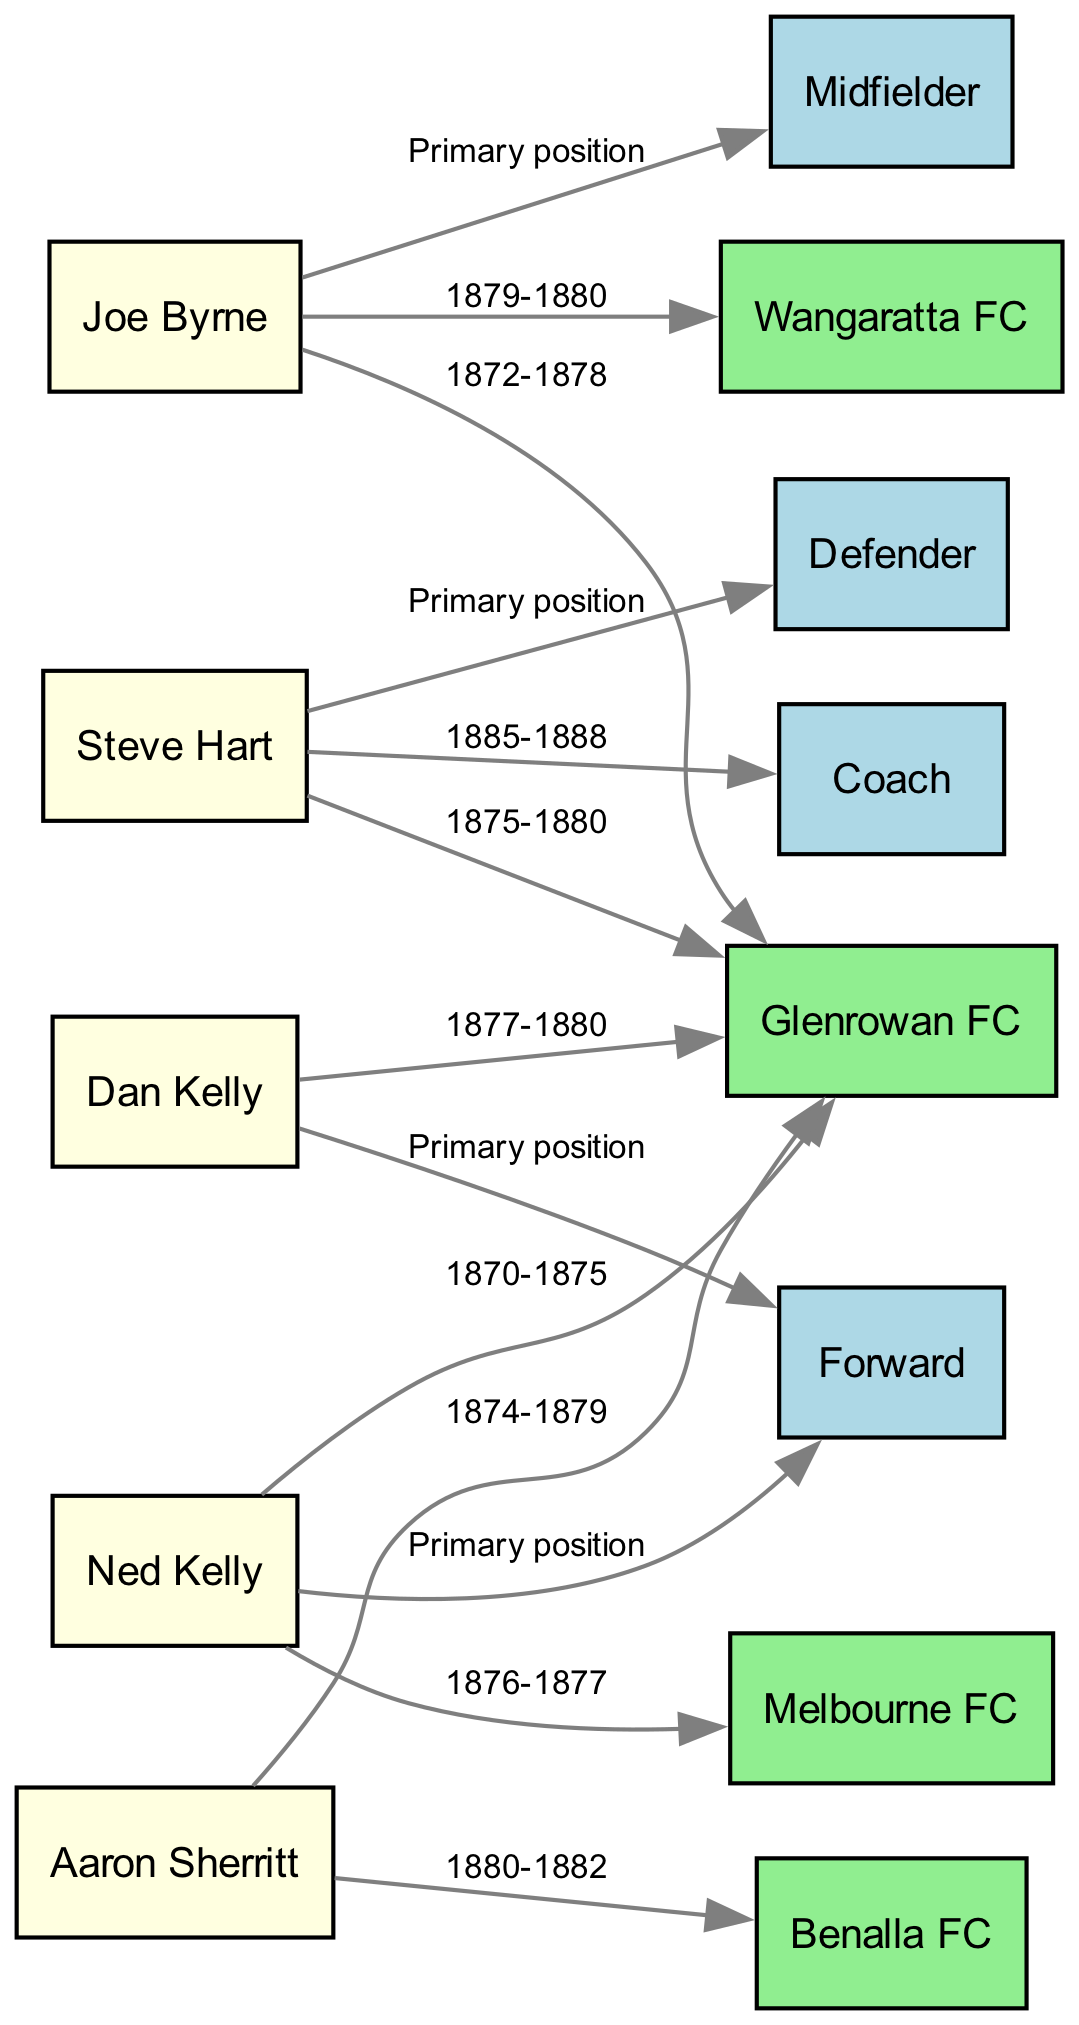What club did Ned Kelly start his career with? To answer this question, I look for the node labeled "Ned Kelly" and then check the edge that connects him to another node. The labeled edge shows that he went to "Glenrowan FC" from 1870 to 1875.
Answer: Glenrowan FC How many players transitioned to Glenrowan FC? I can count the number of nodes that have edges pointing to "Glenrowan FC." From the diagram, I see that there are four players connected to this club: Ned Kelly, Joe Byrne, Steve Hart, and Dan Kelly.
Answer: 4 What was Joe Byrne's primary position? I look for the node labeled "Joe Byrne" and trace the edge leading to his primary position. The edge from Joe Byrne leads to the "Midfielder" node, indicating that this was his primary position.
Answer: Midfielder Which player ended his career as a Coach? I identify which player is connected to the "Coach" node. The edge from "Steve Hart" leading to "Coach" shows that Steve Hart transitioned to this position.
Answer: Steve Hart What team did Aaron Sherritt play for after Glenrowan FC? I find the edge leading from "Aaron Sherritt" to another team. The edge connects "Aaron Sherritt" to "Benalla FC," specifying that this was his next team after his time at Glenrowan FC.
Answer: Benalla FC Which positions are depicted in the diagram? To answer, I can list all the nodes that represent player positions. The positions are "Forward," "Midfielder," "Defender," and "Coach."
Answer: Forward, Midfielder, Defender, Coach Which player had the longest continuous playing period at Glenrowan FC? I compare the time periods of all players associated with "Glenrowan FC" based on the edges. Joe Byrne played for the longest, from 1872 to 1878.
Answer: Joe Byrne What year did Ned Kelly play for Melbourne FC? I check the edge coming from "Ned Kelly" pointing to "Melbourne FC," which carries the label showing the time frame he played there: 1876-1877. This indicates he played there during those years.
Answer: 1876-1877 